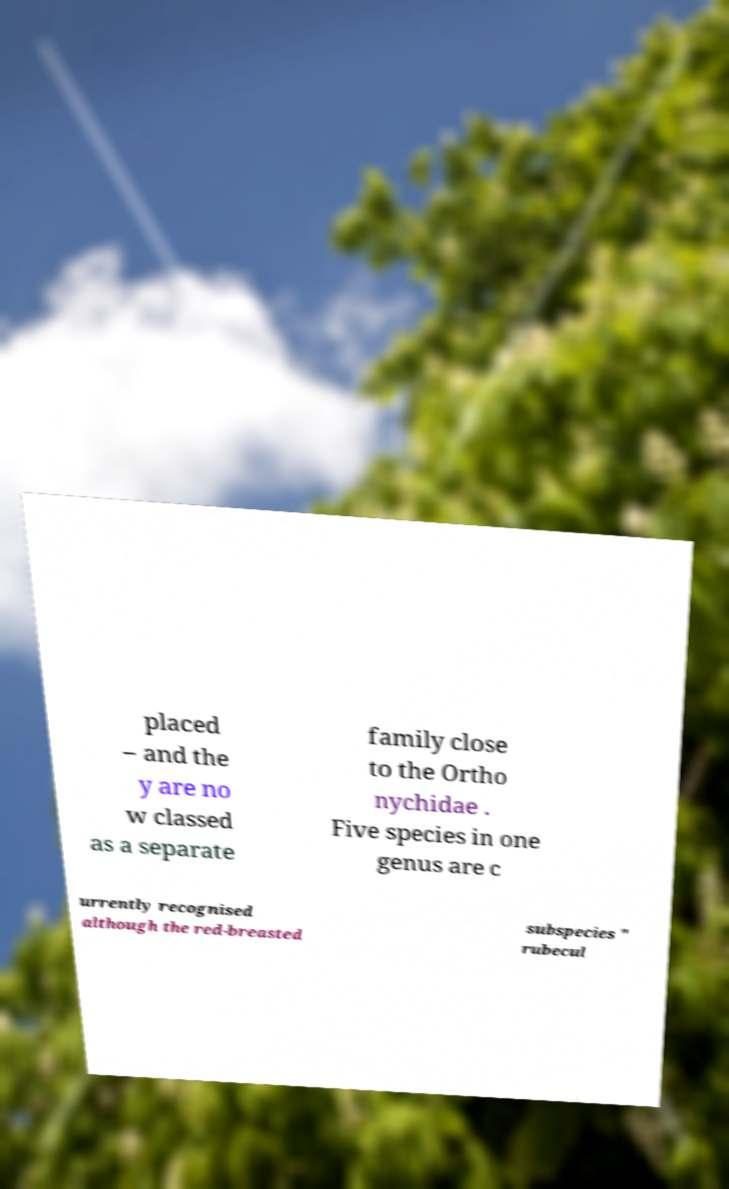Can you accurately transcribe the text from the provided image for me? placed – and the y are no w classed as a separate family close to the Ortho nychidae . Five species in one genus are c urrently recognised although the red-breasted subspecies " rubecul 